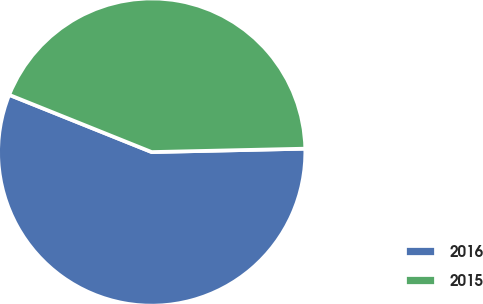<chart> <loc_0><loc_0><loc_500><loc_500><pie_chart><fcel>2016<fcel>2015<nl><fcel>56.43%<fcel>43.57%<nl></chart> 